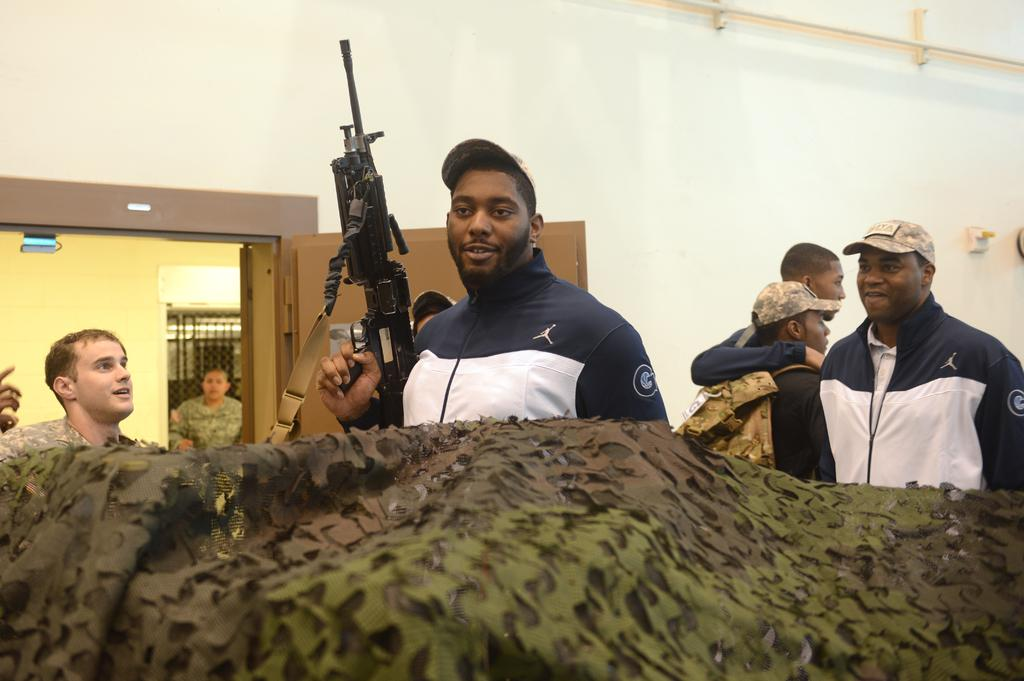What is the person in the image holding? The person is holding a machine gun in the image. Are there any other people in the image? Yes, there are people standing in the image. What can be seen in the background of the image? There is a door visible in the image. How many bikes are parked near the door in the image? There are no bikes present in the image. What action is the person with the machine gun performing in the image? The provided facts do not specify any action being performed by the person with the machine gun. 